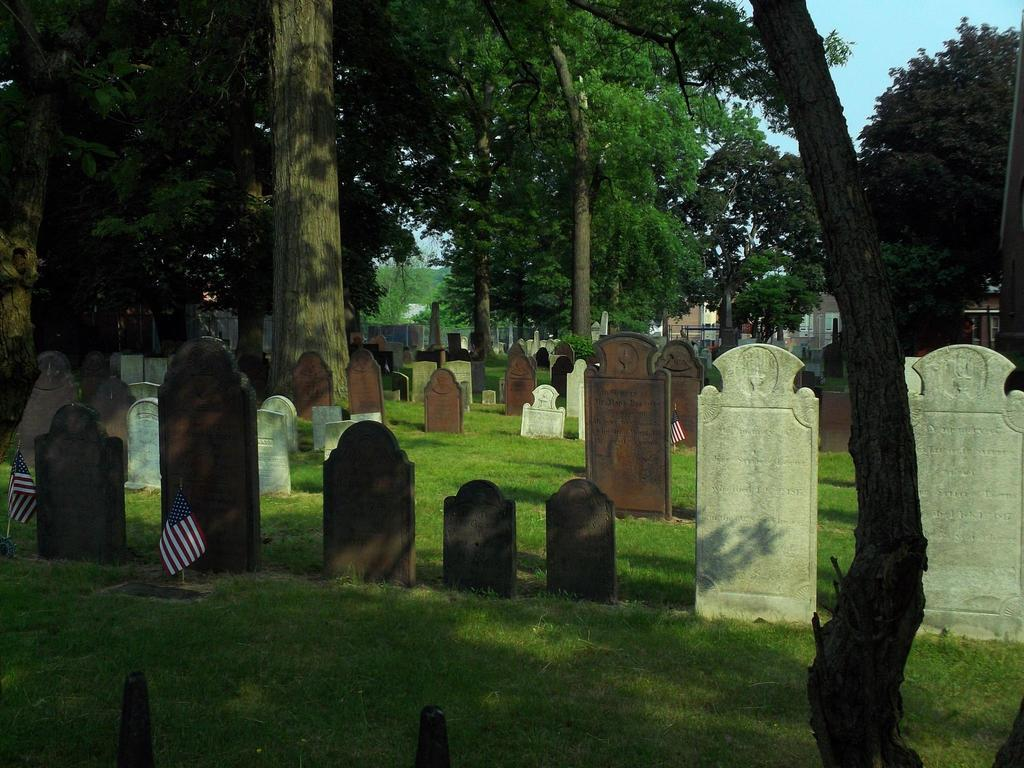What type of location is depicted in the image? The image contains cemeteries. What colors are used to represent the cemeteries in the image? The cemeteries are in brown and white colors. What other objects can be seen in the image? There are flags, trees, buildings, and green grass in the image. What is the color of the sky in the image? The sky is blue in color. Who is the creator of the jelly seen in the image? There is no jelly present in the image, so it is not possible to determine who its creator might be. 